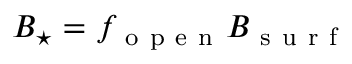Convert formula to latex. <formula><loc_0><loc_0><loc_500><loc_500>B _ { ^ { * } } = f _ { o p e n } B _ { s u r f }</formula> 